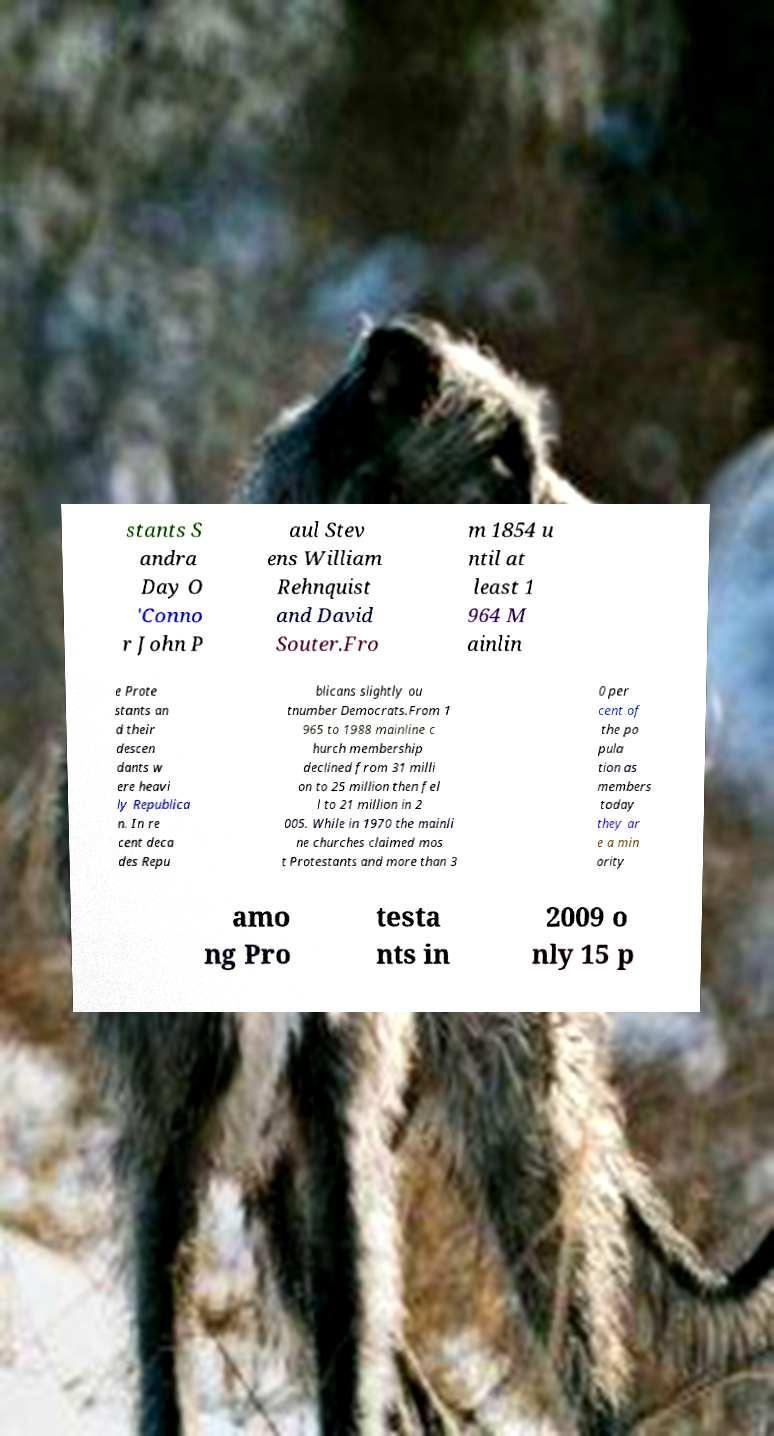Could you extract and type out the text from this image? stants S andra Day O 'Conno r John P aul Stev ens William Rehnquist and David Souter.Fro m 1854 u ntil at least 1 964 M ainlin e Prote stants an d their descen dants w ere heavi ly Republica n. In re cent deca des Repu blicans slightly ou tnumber Democrats.From 1 965 to 1988 mainline c hurch membership declined from 31 milli on to 25 million then fel l to 21 million in 2 005. While in 1970 the mainli ne churches claimed mos t Protestants and more than 3 0 per cent of the po pula tion as members today they ar e a min ority amo ng Pro testa nts in 2009 o nly 15 p 